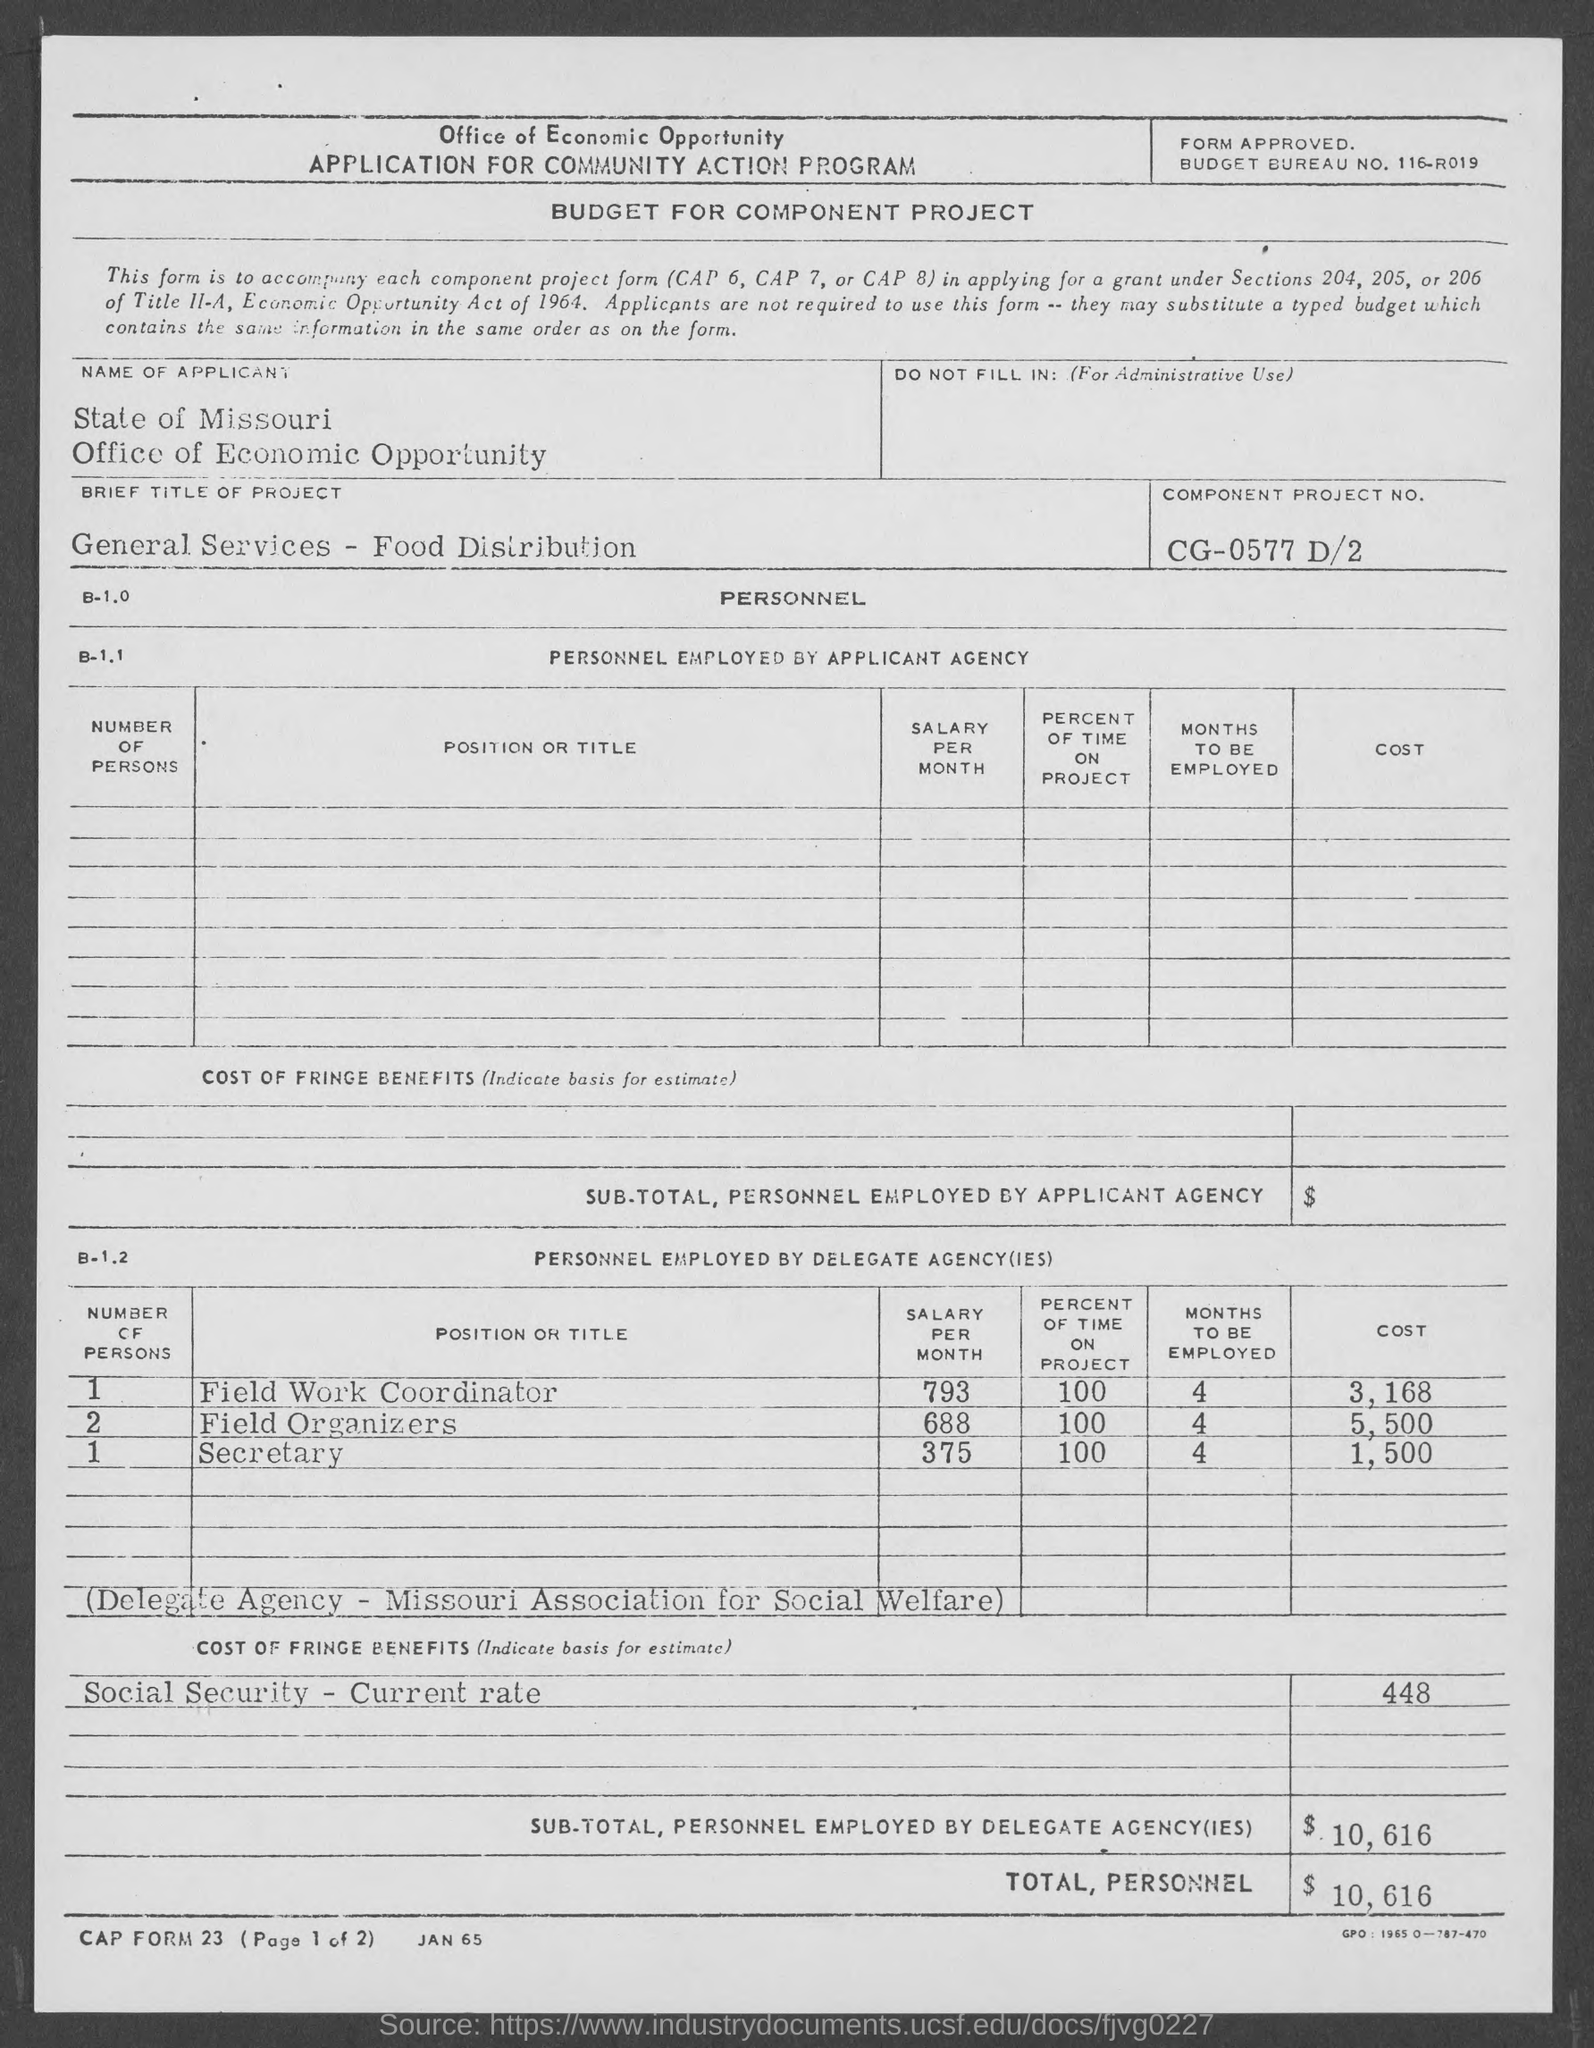List a handful of essential elements in this visual. The total personnel cost is $10,616. The text "what is component Project no.? cg-0577 d/2.." appears to be a request for information about a component and its project number. The project is titled "General Services - Food Distribution. The budget bureau number is 116-r019. 